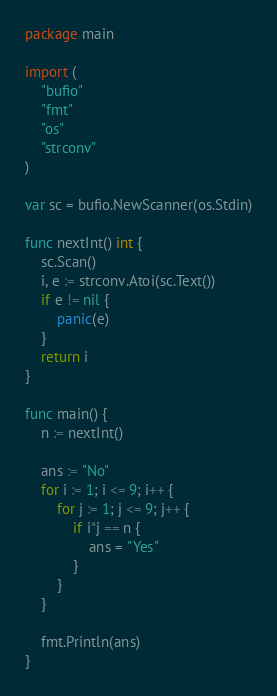Convert code to text. <code><loc_0><loc_0><loc_500><loc_500><_Go_>package main

import (
	"bufio"
	"fmt"
	"os"
	"strconv"
)

var sc = bufio.NewScanner(os.Stdin)

func nextInt() int {
	sc.Scan()
	i, e := strconv.Atoi(sc.Text())
	if e != nil {
		panic(e)
	}
	return i
}

func main() {
	n := nextInt()

	ans := "No"
	for i := 1; i <= 9; i++ {
		for j := 1; j <= 9; j++ {
			if i*j == n {
				ans = "Yes"
			}
		}
	}

	fmt.Println(ans)
}
</code> 